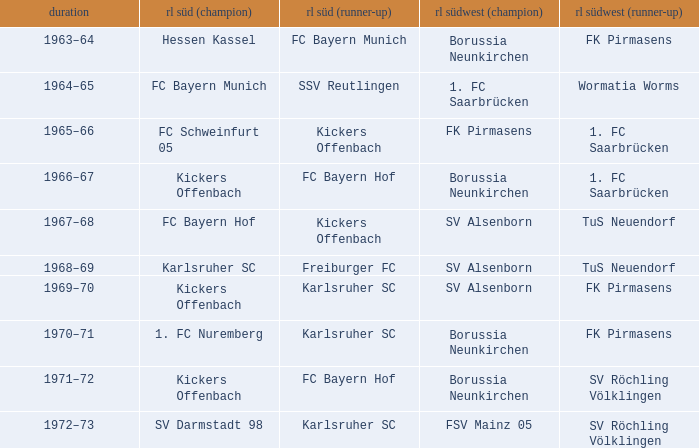When fk pirmasens held the position of rl südwest (1st), who occupied the role of rl süd (1st)? FC Schweinfurt 05. 